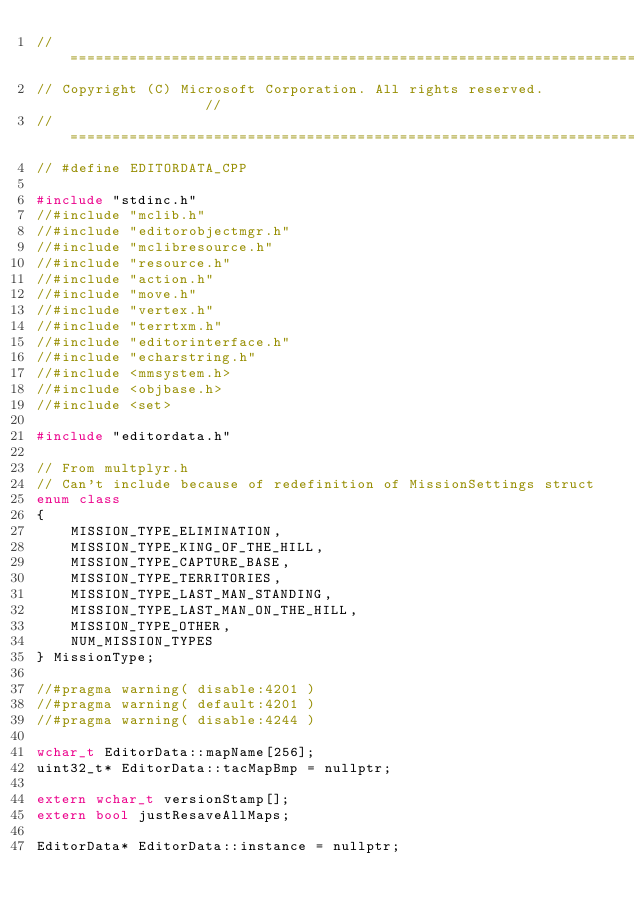Convert code to text. <code><loc_0><loc_0><loc_500><loc_500><_C++_>//===========================================================================//
// Copyright (C) Microsoft Corporation. All rights reserved.                 //
//===========================================================================//
// #define EDITORDATA_CPP

#include "stdinc.h"
//#include "mclib.h"
//#include "editorobjectmgr.h"
//#include "mclibresource.h"
//#include "resource.h"
//#include "action.h"
//#include "move.h"
//#include "vertex.h"
//#include "terrtxm.h"
//#include "editorinterface.h"
//#include "echarstring.h"
//#include <mmsystem.h>
//#include <objbase.h>
//#include <set>

#include "editordata.h"

// From multplyr.h
// Can't include because of redefinition of MissionSettings struct
enum class 
{
	MISSION_TYPE_ELIMINATION,
	MISSION_TYPE_KING_OF_THE_HILL,
	MISSION_TYPE_CAPTURE_BASE,
	MISSION_TYPE_TERRITORIES,
	MISSION_TYPE_LAST_MAN_STANDING,
	MISSION_TYPE_LAST_MAN_ON_THE_HILL,
	MISSION_TYPE_OTHER,
	NUM_MISSION_TYPES
} MissionType;

//#pragma warning( disable:4201 )
//#pragma warning( default:4201 )
//#pragma warning( disable:4244 )

wchar_t EditorData::mapName[256];
uint32_t* EditorData::tacMapBmp = nullptr;

extern wchar_t versionStamp[];
extern bool justResaveAllMaps;

EditorData* EditorData::instance = nullptr;
</code> 